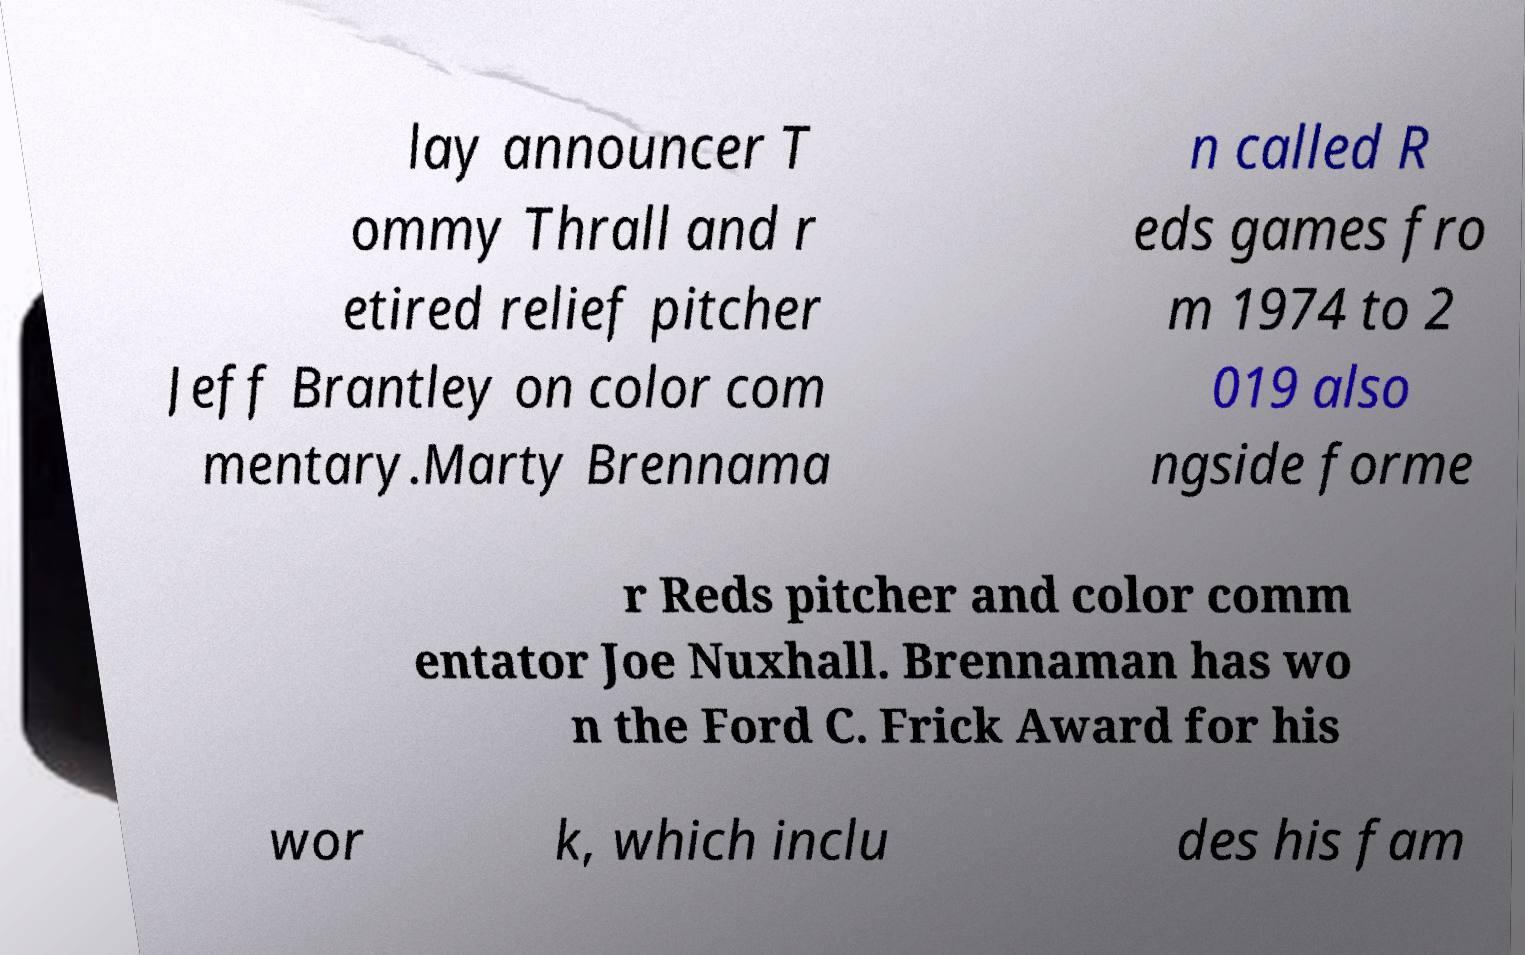Could you extract and type out the text from this image? lay announcer T ommy Thrall and r etired relief pitcher Jeff Brantley on color com mentary.Marty Brennama n called R eds games fro m 1974 to 2 019 also ngside forme r Reds pitcher and color comm entator Joe Nuxhall. Brennaman has wo n the Ford C. Frick Award for his wor k, which inclu des his fam 